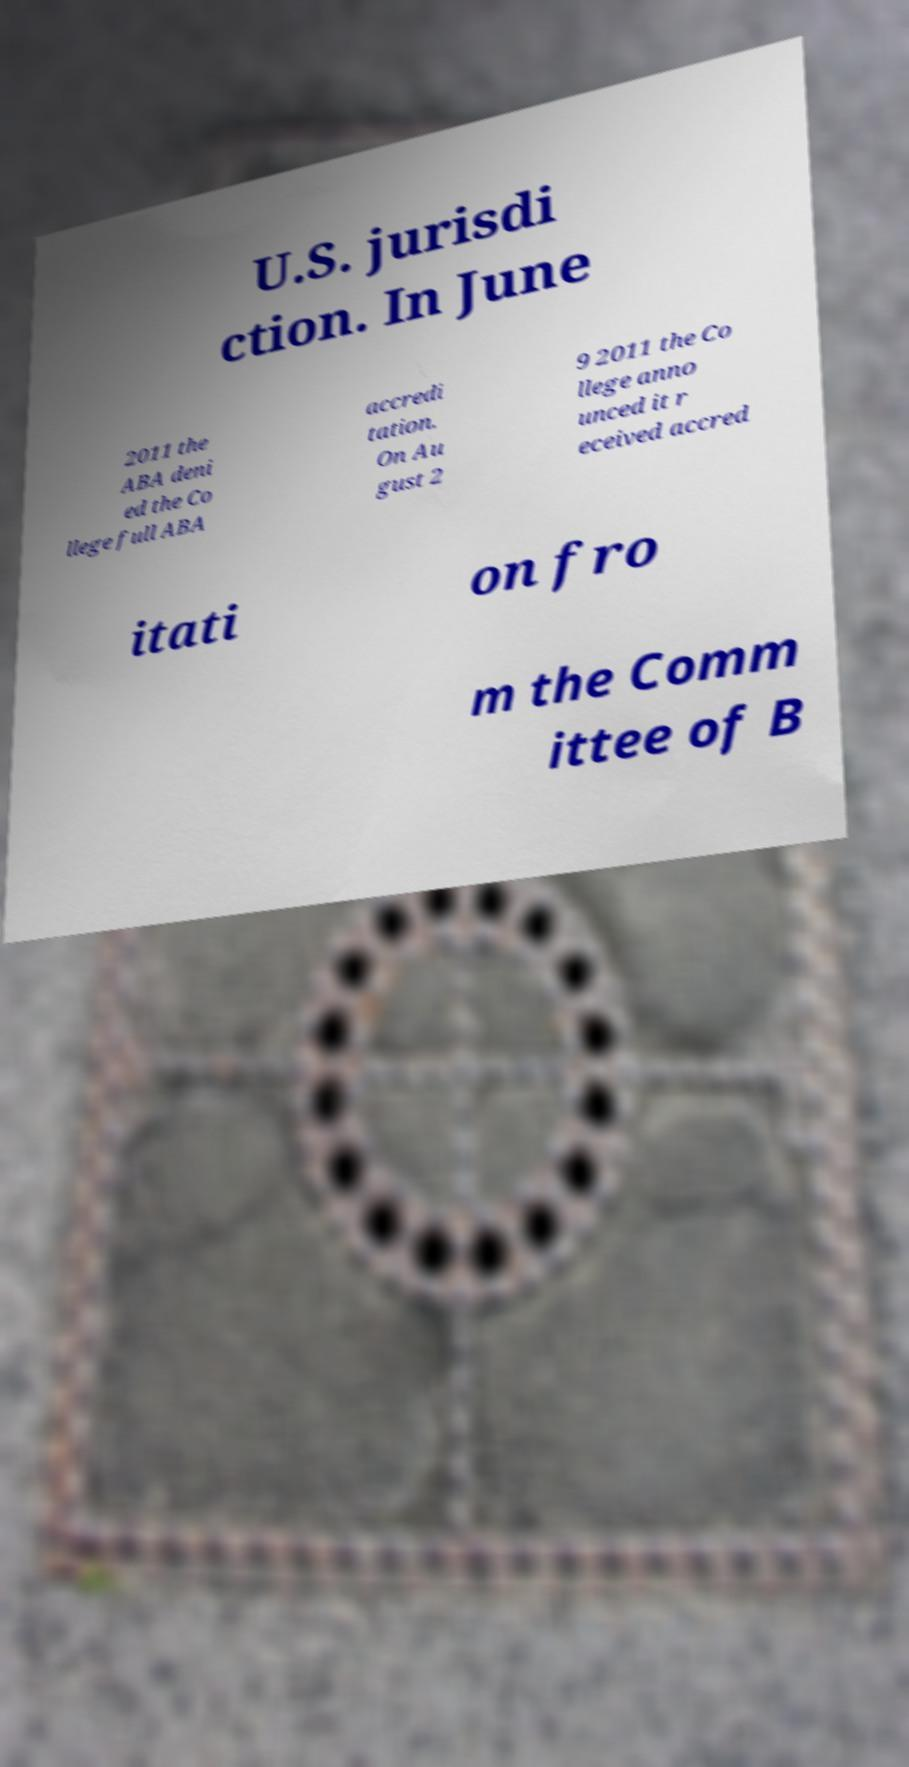Could you extract and type out the text from this image? U.S. jurisdi ction. In June 2011 the ABA deni ed the Co llege full ABA accredi tation. On Au gust 2 9 2011 the Co llege anno unced it r eceived accred itati on fro m the Comm ittee of B 